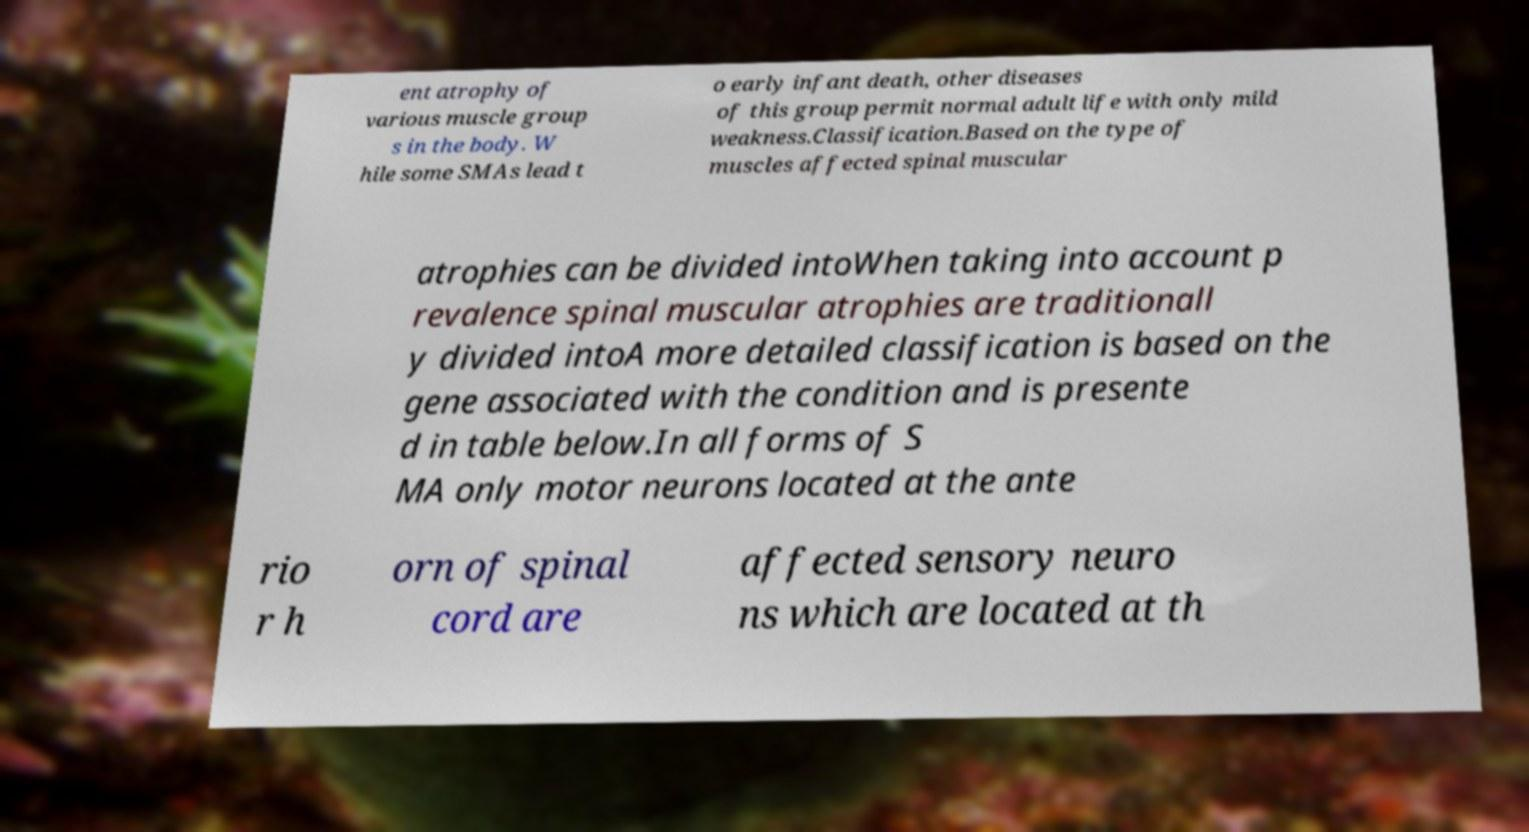Please read and relay the text visible in this image. What does it say? ent atrophy of various muscle group s in the body. W hile some SMAs lead t o early infant death, other diseases of this group permit normal adult life with only mild weakness.Classification.Based on the type of muscles affected spinal muscular atrophies can be divided intoWhen taking into account p revalence spinal muscular atrophies are traditionall y divided intoA more detailed classification is based on the gene associated with the condition and is presente d in table below.In all forms of S MA only motor neurons located at the ante rio r h orn of spinal cord are affected sensory neuro ns which are located at th 